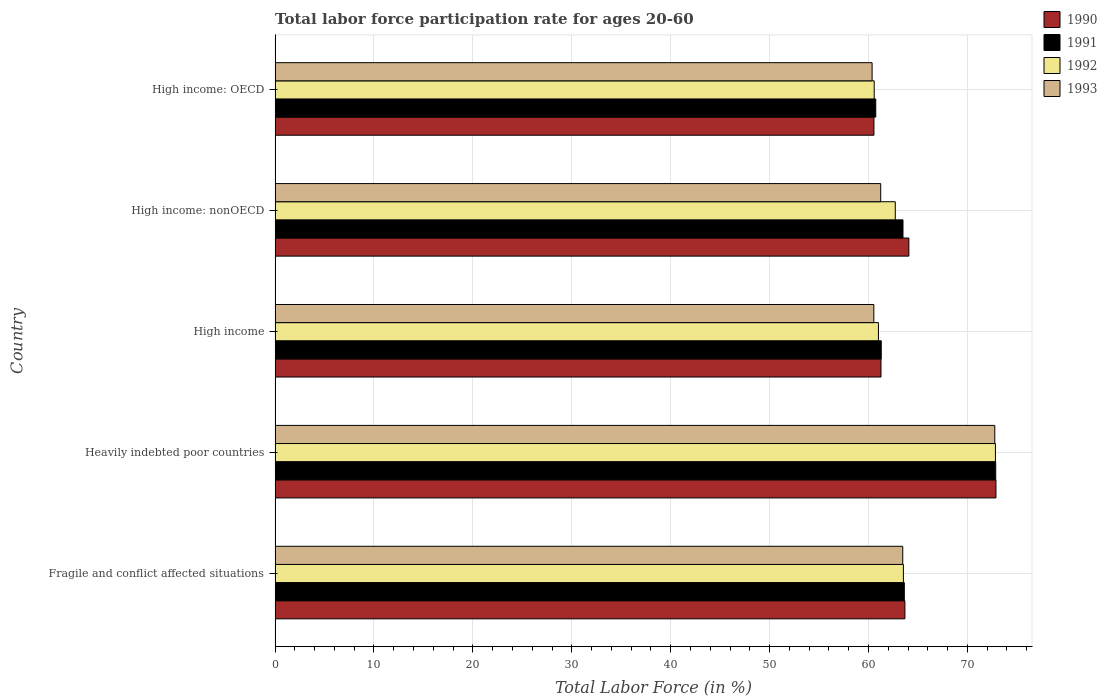How many different coloured bars are there?
Offer a terse response. 4. Are the number of bars per tick equal to the number of legend labels?
Offer a very short reply. Yes. How many bars are there on the 5th tick from the top?
Your answer should be very brief. 4. What is the label of the 1st group of bars from the top?
Ensure brevity in your answer.  High income: OECD. What is the labor force participation rate in 1991 in Fragile and conflict affected situations?
Your response must be concise. 63.62. Across all countries, what is the maximum labor force participation rate in 1993?
Your answer should be compact. 72.77. Across all countries, what is the minimum labor force participation rate in 1993?
Offer a terse response. 60.36. In which country was the labor force participation rate in 1993 maximum?
Make the answer very short. Heavily indebted poor countries. In which country was the labor force participation rate in 1991 minimum?
Offer a terse response. High income: OECD. What is the total labor force participation rate in 1992 in the graph?
Your answer should be compact. 320.65. What is the difference between the labor force participation rate in 1990 in Heavily indebted poor countries and that in High income: OECD?
Make the answer very short. 12.34. What is the difference between the labor force participation rate in 1990 in Heavily indebted poor countries and the labor force participation rate in 1992 in High income: nonOECD?
Keep it short and to the point. 10.18. What is the average labor force participation rate in 1992 per country?
Make the answer very short. 64.13. What is the difference between the labor force participation rate in 1991 and labor force participation rate in 1990 in High income: OECD?
Give a very brief answer. 0.18. In how many countries, is the labor force participation rate in 1991 greater than 48 %?
Provide a short and direct response. 5. What is the ratio of the labor force participation rate in 1991 in Fragile and conflict affected situations to that in High income: nonOECD?
Provide a short and direct response. 1. What is the difference between the highest and the second highest labor force participation rate in 1990?
Offer a terse response. 8.8. What is the difference between the highest and the lowest labor force participation rate in 1991?
Your answer should be very brief. 12.13. Is the sum of the labor force participation rate in 1990 in High income and High income: nonOECD greater than the maximum labor force participation rate in 1991 across all countries?
Provide a succinct answer. Yes. Is it the case that in every country, the sum of the labor force participation rate in 1992 and labor force participation rate in 1991 is greater than the sum of labor force participation rate in 1993 and labor force participation rate in 1990?
Your response must be concise. No. What does the 3rd bar from the top in High income represents?
Provide a succinct answer. 1991. Is it the case that in every country, the sum of the labor force participation rate in 1991 and labor force participation rate in 1993 is greater than the labor force participation rate in 1990?
Make the answer very short. Yes. Are all the bars in the graph horizontal?
Keep it short and to the point. Yes. What is the difference between two consecutive major ticks on the X-axis?
Provide a succinct answer. 10. Does the graph contain grids?
Your answer should be compact. Yes. Where does the legend appear in the graph?
Provide a succinct answer. Top right. What is the title of the graph?
Provide a short and direct response. Total labor force participation rate for ages 20-60. Does "1995" appear as one of the legend labels in the graph?
Make the answer very short. No. What is the label or title of the Y-axis?
Your response must be concise. Country. What is the Total Labor Force (in %) in 1990 in Fragile and conflict affected situations?
Offer a very short reply. 63.68. What is the Total Labor Force (in %) of 1991 in Fragile and conflict affected situations?
Offer a terse response. 63.62. What is the Total Labor Force (in %) of 1992 in Fragile and conflict affected situations?
Your answer should be very brief. 63.53. What is the Total Labor Force (in %) in 1993 in Fragile and conflict affected situations?
Offer a terse response. 63.46. What is the Total Labor Force (in %) of 1990 in Heavily indebted poor countries?
Offer a terse response. 72.89. What is the Total Labor Force (in %) of 1991 in Heavily indebted poor countries?
Your answer should be compact. 72.86. What is the Total Labor Force (in %) in 1992 in Heavily indebted poor countries?
Make the answer very short. 72.83. What is the Total Labor Force (in %) in 1993 in Heavily indebted poor countries?
Your response must be concise. 72.77. What is the Total Labor Force (in %) in 1990 in High income?
Provide a succinct answer. 61.26. What is the Total Labor Force (in %) in 1991 in High income?
Provide a short and direct response. 61.29. What is the Total Labor Force (in %) in 1992 in High income?
Your response must be concise. 61. What is the Total Labor Force (in %) of 1993 in High income?
Provide a succinct answer. 60.54. What is the Total Labor Force (in %) in 1990 in High income: nonOECD?
Your answer should be compact. 64.08. What is the Total Labor Force (in %) in 1991 in High income: nonOECD?
Offer a very short reply. 63.49. What is the Total Labor Force (in %) in 1992 in High income: nonOECD?
Give a very brief answer. 62.71. What is the Total Labor Force (in %) of 1993 in High income: nonOECD?
Provide a succinct answer. 61.23. What is the Total Labor Force (in %) of 1990 in High income: OECD?
Provide a short and direct response. 60.55. What is the Total Labor Force (in %) in 1991 in High income: OECD?
Keep it short and to the point. 60.73. What is the Total Labor Force (in %) of 1992 in High income: OECD?
Offer a terse response. 60.58. What is the Total Labor Force (in %) in 1993 in High income: OECD?
Ensure brevity in your answer.  60.36. Across all countries, what is the maximum Total Labor Force (in %) of 1990?
Keep it short and to the point. 72.89. Across all countries, what is the maximum Total Labor Force (in %) in 1991?
Offer a very short reply. 72.86. Across all countries, what is the maximum Total Labor Force (in %) in 1992?
Your response must be concise. 72.83. Across all countries, what is the maximum Total Labor Force (in %) of 1993?
Offer a very short reply. 72.77. Across all countries, what is the minimum Total Labor Force (in %) of 1990?
Give a very brief answer. 60.55. Across all countries, what is the minimum Total Labor Force (in %) of 1991?
Provide a short and direct response. 60.73. Across all countries, what is the minimum Total Labor Force (in %) in 1992?
Your answer should be compact. 60.58. Across all countries, what is the minimum Total Labor Force (in %) in 1993?
Your response must be concise. 60.36. What is the total Total Labor Force (in %) in 1990 in the graph?
Offer a very short reply. 322.46. What is the total Total Labor Force (in %) in 1991 in the graph?
Offer a very short reply. 321.99. What is the total Total Labor Force (in %) in 1992 in the graph?
Provide a short and direct response. 320.65. What is the total Total Labor Force (in %) in 1993 in the graph?
Provide a short and direct response. 318.36. What is the difference between the Total Labor Force (in %) in 1990 in Fragile and conflict affected situations and that in Heavily indebted poor countries?
Offer a very short reply. -9.21. What is the difference between the Total Labor Force (in %) of 1991 in Fragile and conflict affected situations and that in Heavily indebted poor countries?
Provide a succinct answer. -9.24. What is the difference between the Total Labor Force (in %) in 1992 in Fragile and conflict affected situations and that in Heavily indebted poor countries?
Provide a succinct answer. -9.31. What is the difference between the Total Labor Force (in %) in 1993 in Fragile and conflict affected situations and that in Heavily indebted poor countries?
Your response must be concise. -9.3. What is the difference between the Total Labor Force (in %) of 1990 in Fragile and conflict affected situations and that in High income?
Your answer should be compact. 2.42. What is the difference between the Total Labor Force (in %) in 1991 in Fragile and conflict affected situations and that in High income?
Ensure brevity in your answer.  2.33. What is the difference between the Total Labor Force (in %) of 1992 in Fragile and conflict affected situations and that in High income?
Ensure brevity in your answer.  2.53. What is the difference between the Total Labor Force (in %) of 1993 in Fragile and conflict affected situations and that in High income?
Your answer should be very brief. 2.92. What is the difference between the Total Labor Force (in %) in 1990 in Fragile and conflict affected situations and that in High income: nonOECD?
Keep it short and to the point. -0.4. What is the difference between the Total Labor Force (in %) in 1991 in Fragile and conflict affected situations and that in High income: nonOECD?
Your answer should be compact. 0.13. What is the difference between the Total Labor Force (in %) of 1992 in Fragile and conflict affected situations and that in High income: nonOECD?
Offer a terse response. 0.82. What is the difference between the Total Labor Force (in %) of 1993 in Fragile and conflict affected situations and that in High income: nonOECD?
Give a very brief answer. 2.23. What is the difference between the Total Labor Force (in %) of 1990 in Fragile and conflict affected situations and that in High income: OECD?
Ensure brevity in your answer.  3.13. What is the difference between the Total Labor Force (in %) in 1991 in Fragile and conflict affected situations and that in High income: OECD?
Provide a succinct answer. 2.89. What is the difference between the Total Labor Force (in %) of 1992 in Fragile and conflict affected situations and that in High income: OECD?
Offer a very short reply. 2.95. What is the difference between the Total Labor Force (in %) of 1993 in Fragile and conflict affected situations and that in High income: OECD?
Provide a short and direct response. 3.1. What is the difference between the Total Labor Force (in %) in 1990 in Heavily indebted poor countries and that in High income?
Make the answer very short. 11.62. What is the difference between the Total Labor Force (in %) of 1991 in Heavily indebted poor countries and that in High income?
Give a very brief answer. 11.57. What is the difference between the Total Labor Force (in %) of 1992 in Heavily indebted poor countries and that in High income?
Your answer should be compact. 11.83. What is the difference between the Total Labor Force (in %) of 1993 in Heavily indebted poor countries and that in High income?
Keep it short and to the point. 12.23. What is the difference between the Total Labor Force (in %) of 1990 in Heavily indebted poor countries and that in High income: nonOECD?
Give a very brief answer. 8.8. What is the difference between the Total Labor Force (in %) of 1991 in Heavily indebted poor countries and that in High income: nonOECD?
Your answer should be very brief. 9.37. What is the difference between the Total Labor Force (in %) in 1992 in Heavily indebted poor countries and that in High income: nonOECD?
Offer a very short reply. 10.13. What is the difference between the Total Labor Force (in %) of 1993 in Heavily indebted poor countries and that in High income: nonOECD?
Make the answer very short. 11.53. What is the difference between the Total Labor Force (in %) in 1990 in Heavily indebted poor countries and that in High income: OECD?
Give a very brief answer. 12.34. What is the difference between the Total Labor Force (in %) in 1991 in Heavily indebted poor countries and that in High income: OECD?
Provide a short and direct response. 12.13. What is the difference between the Total Labor Force (in %) of 1992 in Heavily indebted poor countries and that in High income: OECD?
Your answer should be very brief. 12.26. What is the difference between the Total Labor Force (in %) of 1993 in Heavily indebted poor countries and that in High income: OECD?
Ensure brevity in your answer.  12.4. What is the difference between the Total Labor Force (in %) in 1990 in High income and that in High income: nonOECD?
Offer a terse response. -2.82. What is the difference between the Total Labor Force (in %) of 1991 in High income and that in High income: nonOECD?
Your answer should be very brief. -2.2. What is the difference between the Total Labor Force (in %) of 1992 in High income and that in High income: nonOECD?
Your answer should be very brief. -1.7. What is the difference between the Total Labor Force (in %) of 1993 in High income and that in High income: nonOECD?
Provide a short and direct response. -0.7. What is the difference between the Total Labor Force (in %) of 1990 in High income and that in High income: OECD?
Ensure brevity in your answer.  0.71. What is the difference between the Total Labor Force (in %) of 1991 in High income and that in High income: OECD?
Your answer should be compact. 0.55. What is the difference between the Total Labor Force (in %) in 1992 in High income and that in High income: OECD?
Your answer should be very brief. 0.43. What is the difference between the Total Labor Force (in %) of 1993 in High income and that in High income: OECD?
Offer a very short reply. 0.17. What is the difference between the Total Labor Force (in %) in 1990 in High income: nonOECD and that in High income: OECD?
Offer a terse response. 3.53. What is the difference between the Total Labor Force (in %) in 1991 in High income: nonOECD and that in High income: OECD?
Provide a succinct answer. 2.75. What is the difference between the Total Labor Force (in %) in 1992 in High income: nonOECD and that in High income: OECD?
Your response must be concise. 2.13. What is the difference between the Total Labor Force (in %) of 1993 in High income: nonOECD and that in High income: OECD?
Offer a terse response. 0.87. What is the difference between the Total Labor Force (in %) of 1990 in Fragile and conflict affected situations and the Total Labor Force (in %) of 1991 in Heavily indebted poor countries?
Ensure brevity in your answer.  -9.18. What is the difference between the Total Labor Force (in %) in 1990 in Fragile and conflict affected situations and the Total Labor Force (in %) in 1992 in Heavily indebted poor countries?
Keep it short and to the point. -9.15. What is the difference between the Total Labor Force (in %) in 1990 in Fragile and conflict affected situations and the Total Labor Force (in %) in 1993 in Heavily indebted poor countries?
Give a very brief answer. -9.09. What is the difference between the Total Labor Force (in %) in 1991 in Fragile and conflict affected situations and the Total Labor Force (in %) in 1992 in Heavily indebted poor countries?
Your response must be concise. -9.21. What is the difference between the Total Labor Force (in %) in 1991 in Fragile and conflict affected situations and the Total Labor Force (in %) in 1993 in Heavily indebted poor countries?
Ensure brevity in your answer.  -9.15. What is the difference between the Total Labor Force (in %) in 1992 in Fragile and conflict affected situations and the Total Labor Force (in %) in 1993 in Heavily indebted poor countries?
Give a very brief answer. -9.24. What is the difference between the Total Labor Force (in %) in 1990 in Fragile and conflict affected situations and the Total Labor Force (in %) in 1991 in High income?
Offer a terse response. 2.39. What is the difference between the Total Labor Force (in %) of 1990 in Fragile and conflict affected situations and the Total Labor Force (in %) of 1992 in High income?
Keep it short and to the point. 2.68. What is the difference between the Total Labor Force (in %) in 1990 in Fragile and conflict affected situations and the Total Labor Force (in %) in 1993 in High income?
Your answer should be compact. 3.14. What is the difference between the Total Labor Force (in %) in 1991 in Fragile and conflict affected situations and the Total Labor Force (in %) in 1992 in High income?
Provide a short and direct response. 2.62. What is the difference between the Total Labor Force (in %) in 1991 in Fragile and conflict affected situations and the Total Labor Force (in %) in 1993 in High income?
Offer a very short reply. 3.08. What is the difference between the Total Labor Force (in %) of 1992 in Fragile and conflict affected situations and the Total Labor Force (in %) of 1993 in High income?
Offer a very short reply. 2.99. What is the difference between the Total Labor Force (in %) in 1990 in Fragile and conflict affected situations and the Total Labor Force (in %) in 1991 in High income: nonOECD?
Offer a very short reply. 0.19. What is the difference between the Total Labor Force (in %) in 1990 in Fragile and conflict affected situations and the Total Labor Force (in %) in 1992 in High income: nonOECD?
Offer a terse response. 0.97. What is the difference between the Total Labor Force (in %) in 1990 in Fragile and conflict affected situations and the Total Labor Force (in %) in 1993 in High income: nonOECD?
Your response must be concise. 2.45. What is the difference between the Total Labor Force (in %) of 1991 in Fragile and conflict affected situations and the Total Labor Force (in %) of 1992 in High income: nonOECD?
Keep it short and to the point. 0.91. What is the difference between the Total Labor Force (in %) of 1991 in Fragile and conflict affected situations and the Total Labor Force (in %) of 1993 in High income: nonOECD?
Keep it short and to the point. 2.39. What is the difference between the Total Labor Force (in %) in 1992 in Fragile and conflict affected situations and the Total Labor Force (in %) in 1993 in High income: nonOECD?
Your response must be concise. 2.3. What is the difference between the Total Labor Force (in %) in 1990 in Fragile and conflict affected situations and the Total Labor Force (in %) in 1991 in High income: OECD?
Keep it short and to the point. 2.95. What is the difference between the Total Labor Force (in %) in 1990 in Fragile and conflict affected situations and the Total Labor Force (in %) in 1992 in High income: OECD?
Ensure brevity in your answer.  3.1. What is the difference between the Total Labor Force (in %) of 1990 in Fragile and conflict affected situations and the Total Labor Force (in %) of 1993 in High income: OECD?
Offer a terse response. 3.32. What is the difference between the Total Labor Force (in %) of 1991 in Fragile and conflict affected situations and the Total Labor Force (in %) of 1992 in High income: OECD?
Provide a succinct answer. 3.05. What is the difference between the Total Labor Force (in %) of 1991 in Fragile and conflict affected situations and the Total Labor Force (in %) of 1993 in High income: OECD?
Provide a succinct answer. 3.26. What is the difference between the Total Labor Force (in %) in 1992 in Fragile and conflict affected situations and the Total Labor Force (in %) in 1993 in High income: OECD?
Ensure brevity in your answer.  3.17. What is the difference between the Total Labor Force (in %) of 1990 in Heavily indebted poor countries and the Total Labor Force (in %) of 1991 in High income?
Provide a short and direct response. 11.6. What is the difference between the Total Labor Force (in %) of 1990 in Heavily indebted poor countries and the Total Labor Force (in %) of 1992 in High income?
Your response must be concise. 11.88. What is the difference between the Total Labor Force (in %) in 1990 in Heavily indebted poor countries and the Total Labor Force (in %) in 1993 in High income?
Provide a succinct answer. 12.35. What is the difference between the Total Labor Force (in %) of 1991 in Heavily indebted poor countries and the Total Labor Force (in %) of 1992 in High income?
Make the answer very short. 11.86. What is the difference between the Total Labor Force (in %) in 1991 in Heavily indebted poor countries and the Total Labor Force (in %) in 1993 in High income?
Provide a short and direct response. 12.32. What is the difference between the Total Labor Force (in %) of 1992 in Heavily indebted poor countries and the Total Labor Force (in %) of 1993 in High income?
Offer a terse response. 12.3. What is the difference between the Total Labor Force (in %) in 1990 in Heavily indebted poor countries and the Total Labor Force (in %) in 1991 in High income: nonOECD?
Keep it short and to the point. 9.4. What is the difference between the Total Labor Force (in %) in 1990 in Heavily indebted poor countries and the Total Labor Force (in %) in 1992 in High income: nonOECD?
Offer a terse response. 10.18. What is the difference between the Total Labor Force (in %) of 1990 in Heavily indebted poor countries and the Total Labor Force (in %) of 1993 in High income: nonOECD?
Your answer should be compact. 11.65. What is the difference between the Total Labor Force (in %) in 1991 in Heavily indebted poor countries and the Total Labor Force (in %) in 1992 in High income: nonOECD?
Your response must be concise. 10.15. What is the difference between the Total Labor Force (in %) of 1991 in Heavily indebted poor countries and the Total Labor Force (in %) of 1993 in High income: nonOECD?
Your response must be concise. 11.63. What is the difference between the Total Labor Force (in %) in 1992 in Heavily indebted poor countries and the Total Labor Force (in %) in 1993 in High income: nonOECD?
Keep it short and to the point. 11.6. What is the difference between the Total Labor Force (in %) of 1990 in Heavily indebted poor countries and the Total Labor Force (in %) of 1991 in High income: OECD?
Make the answer very short. 12.15. What is the difference between the Total Labor Force (in %) of 1990 in Heavily indebted poor countries and the Total Labor Force (in %) of 1992 in High income: OECD?
Your answer should be very brief. 12.31. What is the difference between the Total Labor Force (in %) in 1990 in Heavily indebted poor countries and the Total Labor Force (in %) in 1993 in High income: OECD?
Give a very brief answer. 12.52. What is the difference between the Total Labor Force (in %) in 1991 in Heavily indebted poor countries and the Total Labor Force (in %) in 1992 in High income: OECD?
Offer a very short reply. 12.29. What is the difference between the Total Labor Force (in %) in 1991 in Heavily indebted poor countries and the Total Labor Force (in %) in 1993 in High income: OECD?
Offer a very short reply. 12.5. What is the difference between the Total Labor Force (in %) of 1992 in Heavily indebted poor countries and the Total Labor Force (in %) of 1993 in High income: OECD?
Give a very brief answer. 12.47. What is the difference between the Total Labor Force (in %) in 1990 in High income and the Total Labor Force (in %) in 1991 in High income: nonOECD?
Your answer should be compact. -2.23. What is the difference between the Total Labor Force (in %) in 1990 in High income and the Total Labor Force (in %) in 1992 in High income: nonOECD?
Give a very brief answer. -1.44. What is the difference between the Total Labor Force (in %) of 1990 in High income and the Total Labor Force (in %) of 1993 in High income: nonOECD?
Keep it short and to the point. 0.03. What is the difference between the Total Labor Force (in %) of 1991 in High income and the Total Labor Force (in %) of 1992 in High income: nonOECD?
Your answer should be compact. -1.42. What is the difference between the Total Labor Force (in %) in 1991 in High income and the Total Labor Force (in %) in 1993 in High income: nonOECD?
Your answer should be compact. 0.06. What is the difference between the Total Labor Force (in %) in 1992 in High income and the Total Labor Force (in %) in 1993 in High income: nonOECD?
Your response must be concise. -0.23. What is the difference between the Total Labor Force (in %) of 1990 in High income and the Total Labor Force (in %) of 1991 in High income: OECD?
Provide a succinct answer. 0.53. What is the difference between the Total Labor Force (in %) of 1990 in High income and the Total Labor Force (in %) of 1992 in High income: OECD?
Give a very brief answer. 0.69. What is the difference between the Total Labor Force (in %) in 1990 in High income and the Total Labor Force (in %) in 1993 in High income: OECD?
Make the answer very short. 0.9. What is the difference between the Total Labor Force (in %) of 1991 in High income and the Total Labor Force (in %) of 1992 in High income: OECD?
Offer a very short reply. 0.71. What is the difference between the Total Labor Force (in %) of 1991 in High income and the Total Labor Force (in %) of 1993 in High income: OECD?
Your response must be concise. 0.93. What is the difference between the Total Labor Force (in %) in 1992 in High income and the Total Labor Force (in %) in 1993 in High income: OECD?
Offer a very short reply. 0.64. What is the difference between the Total Labor Force (in %) in 1990 in High income: nonOECD and the Total Labor Force (in %) in 1991 in High income: OECD?
Give a very brief answer. 3.35. What is the difference between the Total Labor Force (in %) in 1990 in High income: nonOECD and the Total Labor Force (in %) in 1992 in High income: OECD?
Provide a short and direct response. 3.51. What is the difference between the Total Labor Force (in %) in 1990 in High income: nonOECD and the Total Labor Force (in %) in 1993 in High income: OECD?
Provide a succinct answer. 3.72. What is the difference between the Total Labor Force (in %) of 1991 in High income: nonOECD and the Total Labor Force (in %) of 1992 in High income: OECD?
Provide a succinct answer. 2.91. What is the difference between the Total Labor Force (in %) of 1991 in High income: nonOECD and the Total Labor Force (in %) of 1993 in High income: OECD?
Ensure brevity in your answer.  3.12. What is the difference between the Total Labor Force (in %) in 1992 in High income: nonOECD and the Total Labor Force (in %) in 1993 in High income: OECD?
Your response must be concise. 2.34. What is the average Total Labor Force (in %) of 1990 per country?
Your answer should be compact. 64.49. What is the average Total Labor Force (in %) in 1991 per country?
Ensure brevity in your answer.  64.4. What is the average Total Labor Force (in %) in 1992 per country?
Ensure brevity in your answer.  64.13. What is the average Total Labor Force (in %) of 1993 per country?
Give a very brief answer. 63.67. What is the difference between the Total Labor Force (in %) of 1990 and Total Labor Force (in %) of 1991 in Fragile and conflict affected situations?
Ensure brevity in your answer.  0.06. What is the difference between the Total Labor Force (in %) of 1990 and Total Labor Force (in %) of 1992 in Fragile and conflict affected situations?
Your answer should be very brief. 0.15. What is the difference between the Total Labor Force (in %) of 1990 and Total Labor Force (in %) of 1993 in Fragile and conflict affected situations?
Your response must be concise. 0.22. What is the difference between the Total Labor Force (in %) of 1991 and Total Labor Force (in %) of 1992 in Fragile and conflict affected situations?
Provide a short and direct response. 0.09. What is the difference between the Total Labor Force (in %) of 1991 and Total Labor Force (in %) of 1993 in Fragile and conflict affected situations?
Offer a very short reply. 0.16. What is the difference between the Total Labor Force (in %) of 1992 and Total Labor Force (in %) of 1993 in Fragile and conflict affected situations?
Make the answer very short. 0.07. What is the difference between the Total Labor Force (in %) in 1990 and Total Labor Force (in %) in 1991 in Heavily indebted poor countries?
Your response must be concise. 0.02. What is the difference between the Total Labor Force (in %) in 1990 and Total Labor Force (in %) in 1992 in Heavily indebted poor countries?
Offer a very short reply. 0.05. What is the difference between the Total Labor Force (in %) of 1990 and Total Labor Force (in %) of 1993 in Heavily indebted poor countries?
Offer a very short reply. 0.12. What is the difference between the Total Labor Force (in %) of 1991 and Total Labor Force (in %) of 1992 in Heavily indebted poor countries?
Your answer should be very brief. 0.03. What is the difference between the Total Labor Force (in %) of 1991 and Total Labor Force (in %) of 1993 in Heavily indebted poor countries?
Provide a succinct answer. 0.09. What is the difference between the Total Labor Force (in %) in 1992 and Total Labor Force (in %) in 1993 in Heavily indebted poor countries?
Ensure brevity in your answer.  0.07. What is the difference between the Total Labor Force (in %) of 1990 and Total Labor Force (in %) of 1991 in High income?
Keep it short and to the point. -0.03. What is the difference between the Total Labor Force (in %) in 1990 and Total Labor Force (in %) in 1992 in High income?
Give a very brief answer. 0.26. What is the difference between the Total Labor Force (in %) of 1990 and Total Labor Force (in %) of 1993 in High income?
Offer a terse response. 0.73. What is the difference between the Total Labor Force (in %) in 1991 and Total Labor Force (in %) in 1992 in High income?
Your response must be concise. 0.29. What is the difference between the Total Labor Force (in %) of 1991 and Total Labor Force (in %) of 1993 in High income?
Keep it short and to the point. 0.75. What is the difference between the Total Labor Force (in %) in 1992 and Total Labor Force (in %) in 1993 in High income?
Provide a succinct answer. 0.47. What is the difference between the Total Labor Force (in %) in 1990 and Total Labor Force (in %) in 1991 in High income: nonOECD?
Provide a short and direct response. 0.59. What is the difference between the Total Labor Force (in %) of 1990 and Total Labor Force (in %) of 1992 in High income: nonOECD?
Ensure brevity in your answer.  1.38. What is the difference between the Total Labor Force (in %) in 1990 and Total Labor Force (in %) in 1993 in High income: nonOECD?
Ensure brevity in your answer.  2.85. What is the difference between the Total Labor Force (in %) of 1991 and Total Labor Force (in %) of 1992 in High income: nonOECD?
Offer a very short reply. 0.78. What is the difference between the Total Labor Force (in %) in 1991 and Total Labor Force (in %) in 1993 in High income: nonOECD?
Your response must be concise. 2.25. What is the difference between the Total Labor Force (in %) of 1992 and Total Labor Force (in %) of 1993 in High income: nonOECD?
Offer a very short reply. 1.47. What is the difference between the Total Labor Force (in %) of 1990 and Total Labor Force (in %) of 1991 in High income: OECD?
Offer a very short reply. -0.18. What is the difference between the Total Labor Force (in %) in 1990 and Total Labor Force (in %) in 1992 in High income: OECD?
Your answer should be very brief. -0.03. What is the difference between the Total Labor Force (in %) in 1990 and Total Labor Force (in %) in 1993 in High income: OECD?
Keep it short and to the point. 0.19. What is the difference between the Total Labor Force (in %) in 1991 and Total Labor Force (in %) in 1992 in High income: OECD?
Offer a very short reply. 0.16. What is the difference between the Total Labor Force (in %) in 1991 and Total Labor Force (in %) in 1993 in High income: OECD?
Your answer should be very brief. 0.37. What is the difference between the Total Labor Force (in %) of 1992 and Total Labor Force (in %) of 1993 in High income: OECD?
Give a very brief answer. 0.21. What is the ratio of the Total Labor Force (in %) of 1990 in Fragile and conflict affected situations to that in Heavily indebted poor countries?
Provide a short and direct response. 0.87. What is the ratio of the Total Labor Force (in %) in 1991 in Fragile and conflict affected situations to that in Heavily indebted poor countries?
Give a very brief answer. 0.87. What is the ratio of the Total Labor Force (in %) of 1992 in Fragile and conflict affected situations to that in Heavily indebted poor countries?
Make the answer very short. 0.87. What is the ratio of the Total Labor Force (in %) in 1993 in Fragile and conflict affected situations to that in Heavily indebted poor countries?
Ensure brevity in your answer.  0.87. What is the ratio of the Total Labor Force (in %) in 1990 in Fragile and conflict affected situations to that in High income?
Provide a short and direct response. 1.04. What is the ratio of the Total Labor Force (in %) in 1991 in Fragile and conflict affected situations to that in High income?
Keep it short and to the point. 1.04. What is the ratio of the Total Labor Force (in %) in 1992 in Fragile and conflict affected situations to that in High income?
Provide a short and direct response. 1.04. What is the ratio of the Total Labor Force (in %) of 1993 in Fragile and conflict affected situations to that in High income?
Your response must be concise. 1.05. What is the ratio of the Total Labor Force (in %) of 1990 in Fragile and conflict affected situations to that in High income: nonOECD?
Provide a succinct answer. 0.99. What is the ratio of the Total Labor Force (in %) of 1991 in Fragile and conflict affected situations to that in High income: nonOECD?
Provide a succinct answer. 1. What is the ratio of the Total Labor Force (in %) in 1992 in Fragile and conflict affected situations to that in High income: nonOECD?
Keep it short and to the point. 1.01. What is the ratio of the Total Labor Force (in %) in 1993 in Fragile and conflict affected situations to that in High income: nonOECD?
Provide a succinct answer. 1.04. What is the ratio of the Total Labor Force (in %) in 1990 in Fragile and conflict affected situations to that in High income: OECD?
Give a very brief answer. 1.05. What is the ratio of the Total Labor Force (in %) of 1991 in Fragile and conflict affected situations to that in High income: OECD?
Your response must be concise. 1.05. What is the ratio of the Total Labor Force (in %) of 1992 in Fragile and conflict affected situations to that in High income: OECD?
Make the answer very short. 1.05. What is the ratio of the Total Labor Force (in %) of 1993 in Fragile and conflict affected situations to that in High income: OECD?
Offer a terse response. 1.05. What is the ratio of the Total Labor Force (in %) in 1990 in Heavily indebted poor countries to that in High income?
Your answer should be very brief. 1.19. What is the ratio of the Total Labor Force (in %) of 1991 in Heavily indebted poor countries to that in High income?
Your answer should be compact. 1.19. What is the ratio of the Total Labor Force (in %) of 1992 in Heavily indebted poor countries to that in High income?
Keep it short and to the point. 1.19. What is the ratio of the Total Labor Force (in %) of 1993 in Heavily indebted poor countries to that in High income?
Offer a terse response. 1.2. What is the ratio of the Total Labor Force (in %) of 1990 in Heavily indebted poor countries to that in High income: nonOECD?
Give a very brief answer. 1.14. What is the ratio of the Total Labor Force (in %) in 1991 in Heavily indebted poor countries to that in High income: nonOECD?
Offer a terse response. 1.15. What is the ratio of the Total Labor Force (in %) of 1992 in Heavily indebted poor countries to that in High income: nonOECD?
Make the answer very short. 1.16. What is the ratio of the Total Labor Force (in %) in 1993 in Heavily indebted poor countries to that in High income: nonOECD?
Your response must be concise. 1.19. What is the ratio of the Total Labor Force (in %) of 1990 in Heavily indebted poor countries to that in High income: OECD?
Provide a short and direct response. 1.2. What is the ratio of the Total Labor Force (in %) in 1991 in Heavily indebted poor countries to that in High income: OECD?
Offer a terse response. 1.2. What is the ratio of the Total Labor Force (in %) in 1992 in Heavily indebted poor countries to that in High income: OECD?
Your answer should be very brief. 1.2. What is the ratio of the Total Labor Force (in %) in 1993 in Heavily indebted poor countries to that in High income: OECD?
Your response must be concise. 1.21. What is the ratio of the Total Labor Force (in %) of 1990 in High income to that in High income: nonOECD?
Make the answer very short. 0.96. What is the ratio of the Total Labor Force (in %) of 1991 in High income to that in High income: nonOECD?
Make the answer very short. 0.97. What is the ratio of the Total Labor Force (in %) of 1992 in High income to that in High income: nonOECD?
Provide a short and direct response. 0.97. What is the ratio of the Total Labor Force (in %) of 1990 in High income to that in High income: OECD?
Your answer should be compact. 1.01. What is the ratio of the Total Labor Force (in %) in 1991 in High income to that in High income: OECD?
Your response must be concise. 1.01. What is the ratio of the Total Labor Force (in %) in 1992 in High income to that in High income: OECD?
Offer a terse response. 1.01. What is the ratio of the Total Labor Force (in %) in 1990 in High income: nonOECD to that in High income: OECD?
Ensure brevity in your answer.  1.06. What is the ratio of the Total Labor Force (in %) of 1991 in High income: nonOECD to that in High income: OECD?
Offer a terse response. 1.05. What is the ratio of the Total Labor Force (in %) of 1992 in High income: nonOECD to that in High income: OECD?
Make the answer very short. 1.04. What is the ratio of the Total Labor Force (in %) of 1993 in High income: nonOECD to that in High income: OECD?
Give a very brief answer. 1.01. What is the difference between the highest and the second highest Total Labor Force (in %) of 1990?
Your response must be concise. 8.8. What is the difference between the highest and the second highest Total Labor Force (in %) in 1991?
Your response must be concise. 9.24. What is the difference between the highest and the second highest Total Labor Force (in %) in 1992?
Make the answer very short. 9.31. What is the difference between the highest and the second highest Total Labor Force (in %) of 1993?
Give a very brief answer. 9.3. What is the difference between the highest and the lowest Total Labor Force (in %) in 1990?
Make the answer very short. 12.34. What is the difference between the highest and the lowest Total Labor Force (in %) of 1991?
Your answer should be very brief. 12.13. What is the difference between the highest and the lowest Total Labor Force (in %) in 1992?
Keep it short and to the point. 12.26. What is the difference between the highest and the lowest Total Labor Force (in %) in 1993?
Offer a terse response. 12.4. 